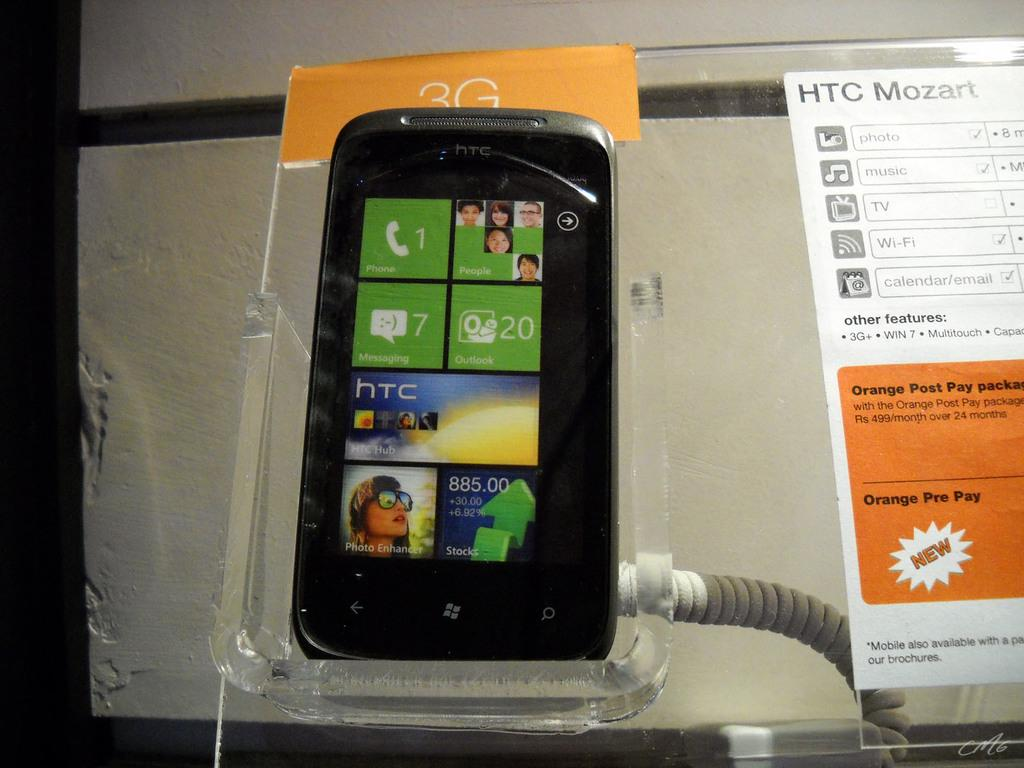What is the main object in the image? There is a mobile with a screen in the image. How is the mobile positioned in the image? The mobile is placed on a glass stand. Are there any additional decorative elements in the image? Yes, there are two stickers in the image. What can be seen in the background of the image? The background of the image includes a wall. Is there any wire visible in the image? Yes, there is a wire in the image. Can you tell me how many cattle are visible in the image? There are no cattle present in the image. What type of sink is shown in the image? There is no sink present in the image. 